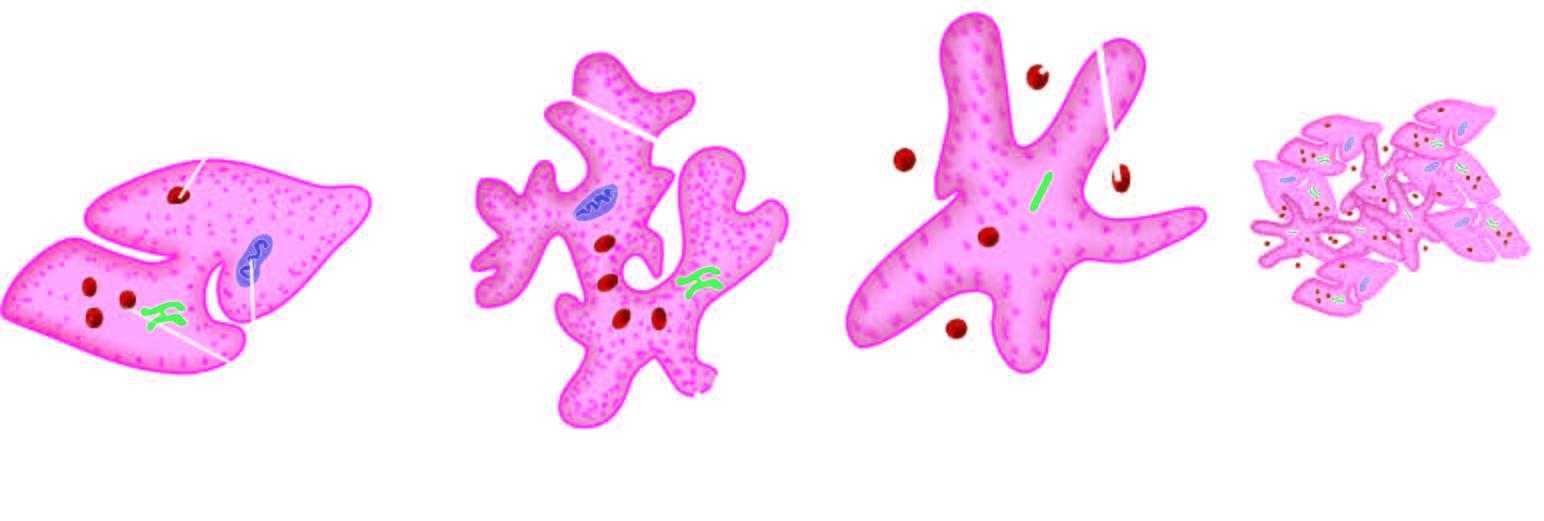s normal non-activated platelet, having open canalicular system and the cytoplasmic organelles dispersed in the cell?
Answer the question using a single word or phrase. Yes 